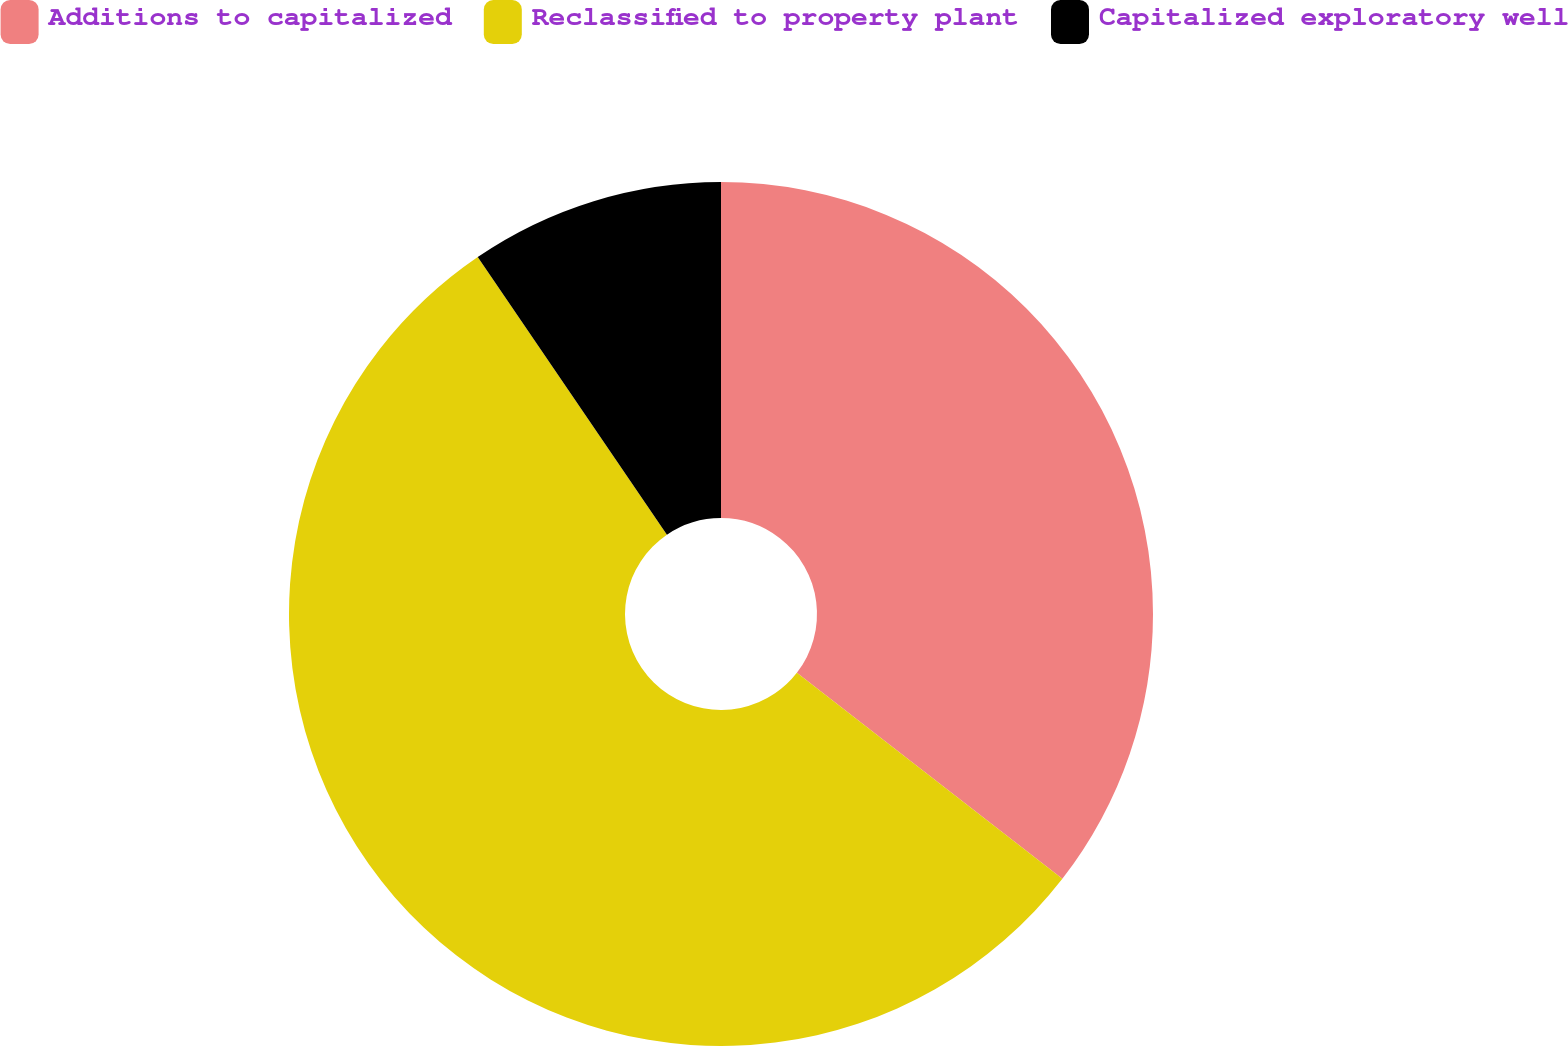<chart> <loc_0><loc_0><loc_500><loc_500><pie_chart><fcel>Additions to capitalized<fcel>Reclassified to property plant<fcel>Capitalized exploratory well<nl><fcel>35.5%<fcel>54.98%<fcel>9.52%<nl></chart> 